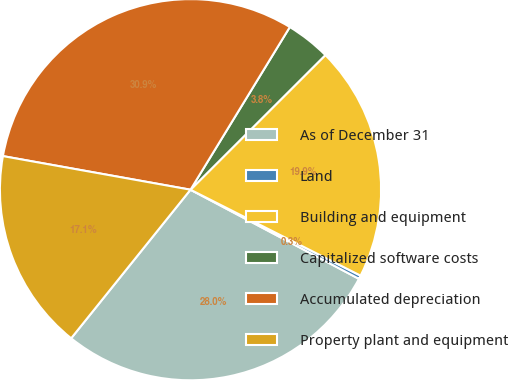<chart> <loc_0><loc_0><loc_500><loc_500><pie_chart><fcel>As of December 31<fcel>Land<fcel>Building and equipment<fcel>Capitalized software costs<fcel>Accumulated depreciation<fcel>Property plant and equipment<nl><fcel>28.02%<fcel>0.3%<fcel>19.93%<fcel>3.79%<fcel>30.9%<fcel>17.05%<nl></chart> 